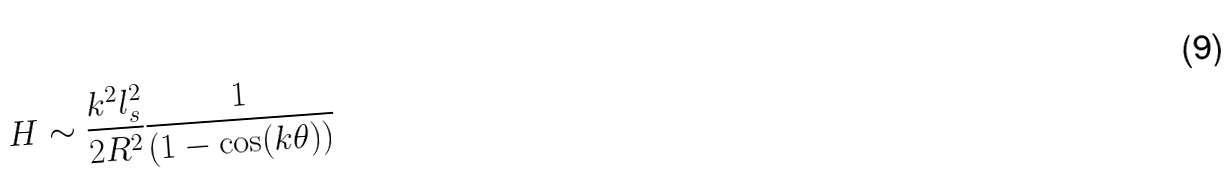<formula> <loc_0><loc_0><loc_500><loc_500>H \sim \frac { k ^ { 2 } l _ { s } ^ { 2 } } { 2 R ^ { 2 } } \frac { 1 } { ( 1 - \cos ( k \theta ) ) }</formula> 